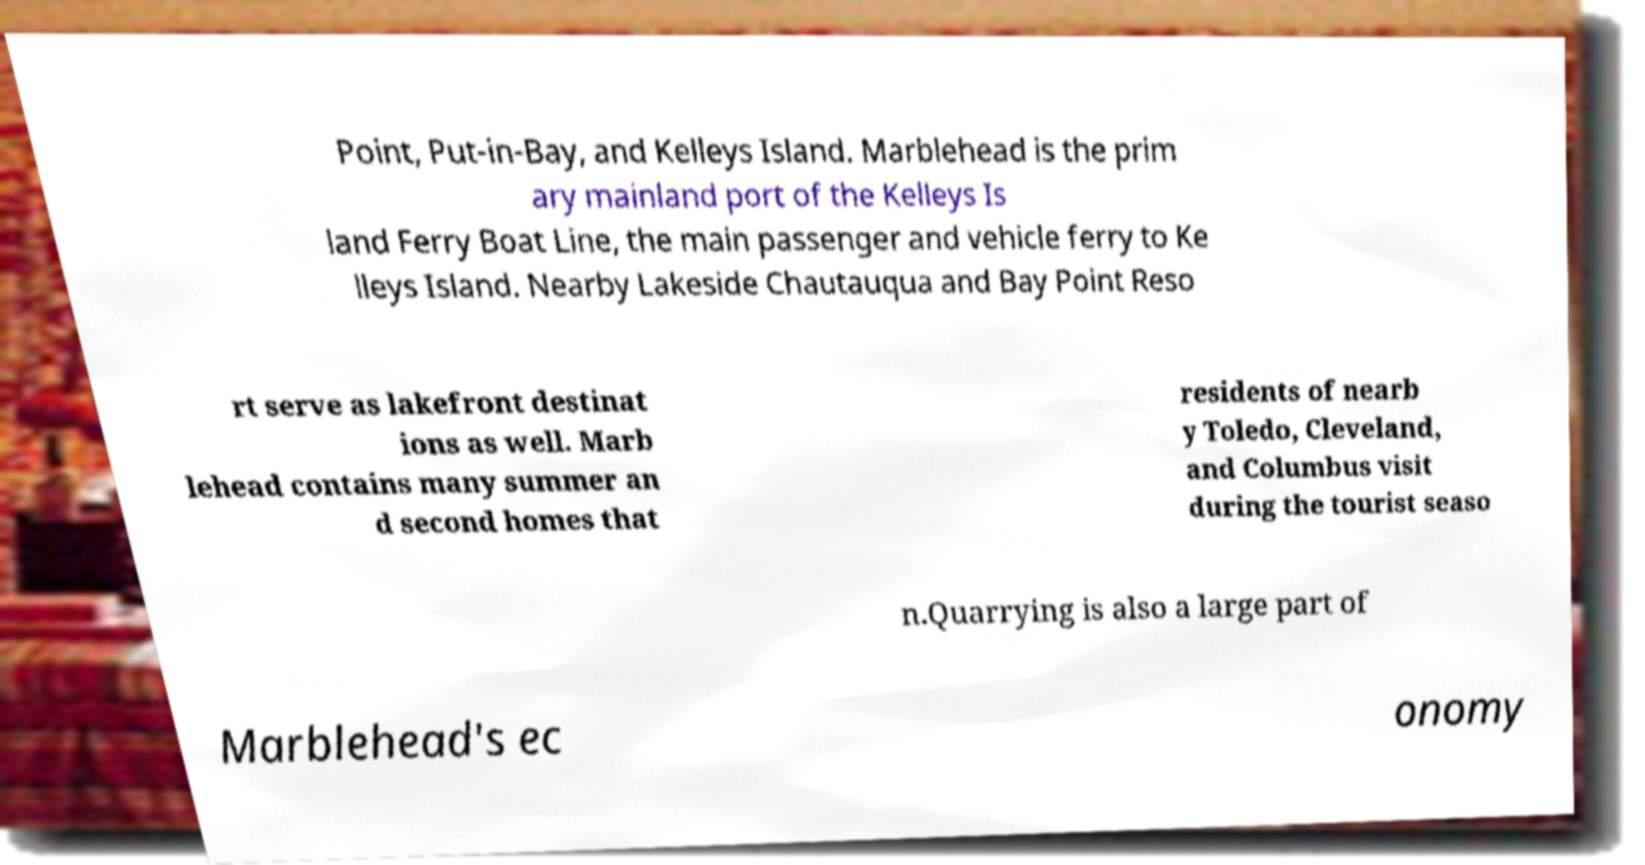Can you read and provide the text displayed in the image?This photo seems to have some interesting text. Can you extract and type it out for me? Point, Put-in-Bay, and Kelleys Island. Marblehead is the prim ary mainland port of the Kelleys Is land Ferry Boat Line, the main passenger and vehicle ferry to Ke lleys Island. Nearby Lakeside Chautauqua and Bay Point Reso rt serve as lakefront destinat ions as well. Marb lehead contains many summer an d second homes that residents of nearb y Toledo, Cleveland, and Columbus visit during the tourist seaso n.Quarrying is also a large part of Marblehead's ec onomy 